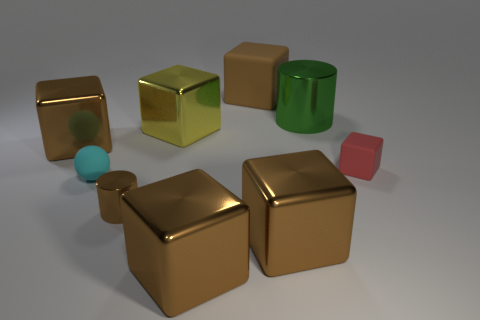Are there any tiny blue cylinders made of the same material as the yellow thing?
Keep it short and to the point. No. There is a tiny matte thing on the left side of the brown cylinder; is it the same color as the large rubber object?
Keep it short and to the point. No. Are there an equal number of matte things that are on the left side of the cyan object and large blue rubber balls?
Give a very brief answer. Yes. Are there any big metallic cylinders of the same color as the big rubber block?
Keep it short and to the point. No. Is the size of the red block the same as the yellow metallic object?
Give a very brief answer. No. There is a metal cylinder that is in front of the matte thing to the left of the large yellow shiny block; what size is it?
Ensure brevity in your answer.  Small. There is a rubber thing that is both in front of the yellow thing and to the left of the small rubber block; what size is it?
Your response must be concise. Small. What number of shiny cubes have the same size as the brown matte cube?
Provide a short and direct response. 4. What number of matte objects are either cyan objects or yellow things?
Make the answer very short. 1. There is a metallic cylinder that is the same color as the big matte block; what size is it?
Offer a terse response. Small. 